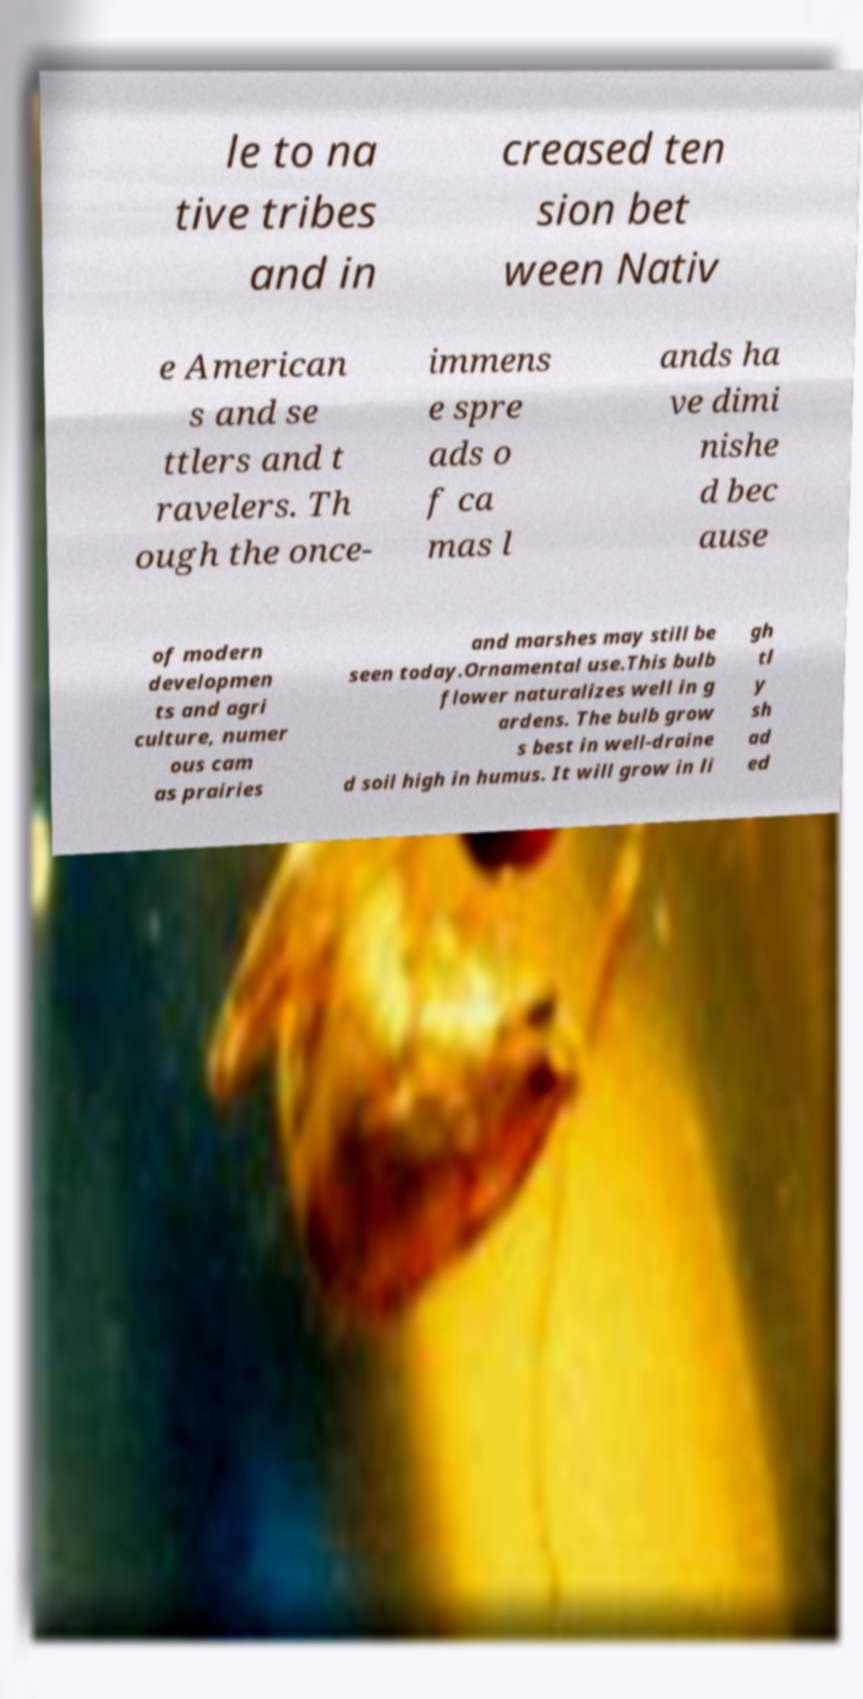Please read and relay the text visible in this image. What does it say? le to na tive tribes and in creased ten sion bet ween Nativ e American s and se ttlers and t ravelers. Th ough the once- immens e spre ads o f ca mas l ands ha ve dimi nishe d bec ause of modern developmen ts and agri culture, numer ous cam as prairies and marshes may still be seen today.Ornamental use.This bulb flower naturalizes well in g ardens. The bulb grow s best in well-draine d soil high in humus. It will grow in li gh tl y sh ad ed 